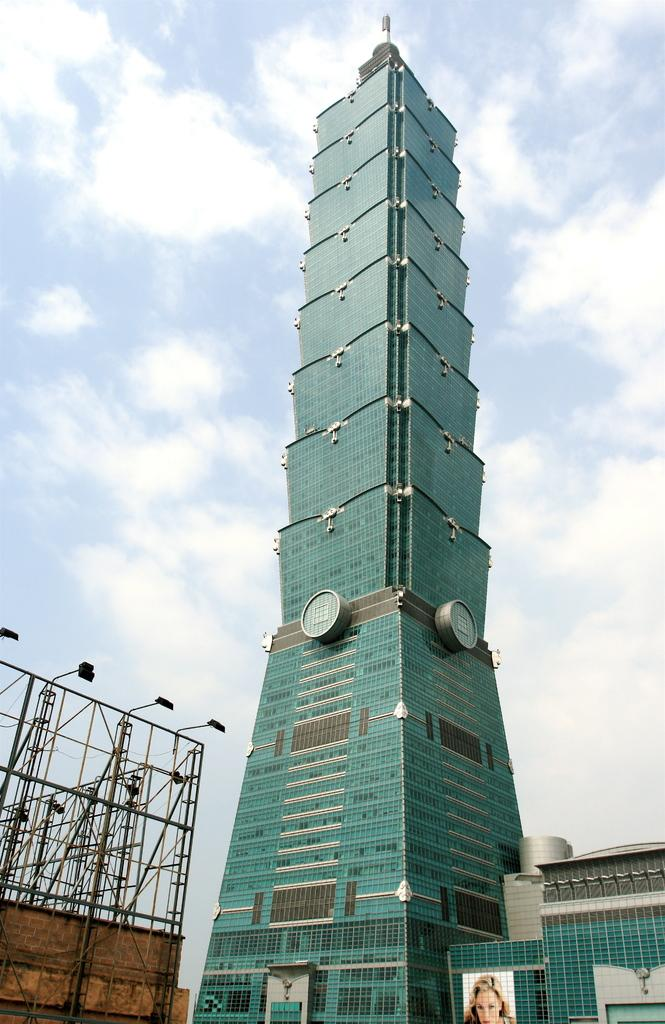What type of building is in the image? There is a skyscraper in the image. What color is the skyscraper? The skyscraper is green in color. What can be seen on the left side of the image? There is a stand of a hoarding on the left side of the image. What is visible at the top of the image? There are clouds visible at the top of the image. Can you hear the pig cry in the image? There is no pig or any sound present in the image, as it is a static visual representation. 